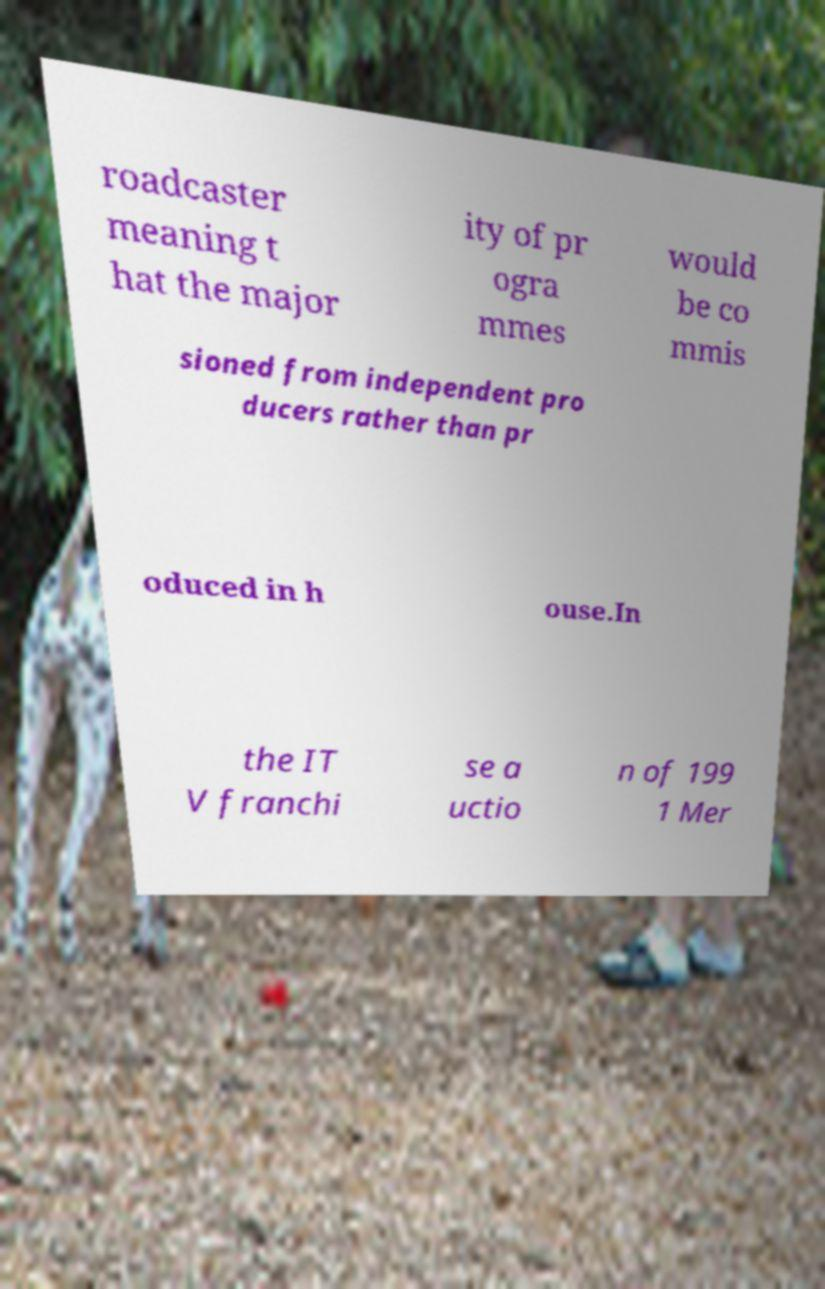Please read and relay the text visible in this image. What does it say? roadcaster meaning t hat the major ity of pr ogra mmes would be co mmis sioned from independent pro ducers rather than pr oduced in h ouse.In the IT V franchi se a uctio n of 199 1 Mer 